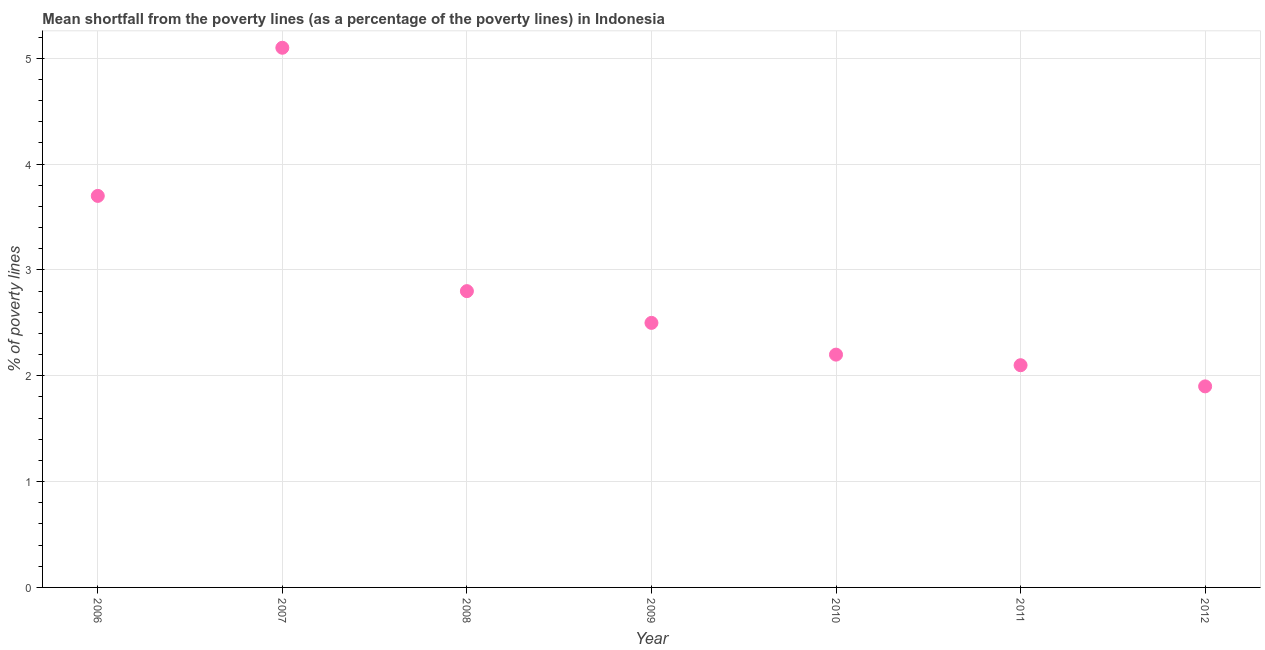What is the poverty gap at national poverty lines in 2006?
Offer a terse response. 3.7. In which year was the poverty gap at national poverty lines minimum?
Your answer should be very brief. 2012. What is the sum of the poverty gap at national poverty lines?
Ensure brevity in your answer.  20.3. What is the difference between the poverty gap at national poverty lines in 2008 and 2011?
Give a very brief answer. 0.7. What is the median poverty gap at national poverty lines?
Offer a very short reply. 2.5. What is the ratio of the poverty gap at national poverty lines in 2008 to that in 2009?
Make the answer very short. 1.12. Is the difference between the poverty gap at national poverty lines in 2009 and 2011 greater than the difference between any two years?
Your answer should be compact. No. What is the difference between the highest and the second highest poverty gap at national poverty lines?
Provide a short and direct response. 1.4. Is the sum of the poverty gap at national poverty lines in 2009 and 2011 greater than the maximum poverty gap at national poverty lines across all years?
Provide a short and direct response. No. What is the difference between the highest and the lowest poverty gap at national poverty lines?
Keep it short and to the point. 3.2. In how many years, is the poverty gap at national poverty lines greater than the average poverty gap at national poverty lines taken over all years?
Your answer should be very brief. 2. How many years are there in the graph?
Offer a very short reply. 7. Are the values on the major ticks of Y-axis written in scientific E-notation?
Offer a terse response. No. What is the title of the graph?
Provide a short and direct response. Mean shortfall from the poverty lines (as a percentage of the poverty lines) in Indonesia. What is the label or title of the Y-axis?
Your answer should be compact. % of poverty lines. What is the % of poverty lines in 2008?
Give a very brief answer. 2.8. What is the % of poverty lines in 2011?
Your answer should be compact. 2.1. What is the difference between the % of poverty lines in 2006 and 2007?
Give a very brief answer. -1.4. What is the difference between the % of poverty lines in 2006 and 2009?
Your answer should be compact. 1.2. What is the difference between the % of poverty lines in 2006 and 2012?
Your response must be concise. 1.8. What is the difference between the % of poverty lines in 2007 and 2008?
Give a very brief answer. 2.3. What is the difference between the % of poverty lines in 2007 and 2011?
Your response must be concise. 3. What is the difference between the % of poverty lines in 2008 and 2009?
Your answer should be compact. 0.3. What is the difference between the % of poverty lines in 2008 and 2010?
Your response must be concise. 0.6. What is the difference between the % of poverty lines in 2008 and 2012?
Offer a terse response. 0.9. What is the difference between the % of poverty lines in 2009 and 2010?
Your answer should be very brief. 0.3. What is the difference between the % of poverty lines in 2009 and 2012?
Provide a short and direct response. 0.6. What is the difference between the % of poverty lines in 2010 and 2011?
Provide a short and direct response. 0.1. What is the difference between the % of poverty lines in 2010 and 2012?
Your response must be concise. 0.3. What is the ratio of the % of poverty lines in 2006 to that in 2007?
Provide a succinct answer. 0.72. What is the ratio of the % of poverty lines in 2006 to that in 2008?
Offer a terse response. 1.32. What is the ratio of the % of poverty lines in 2006 to that in 2009?
Your answer should be very brief. 1.48. What is the ratio of the % of poverty lines in 2006 to that in 2010?
Give a very brief answer. 1.68. What is the ratio of the % of poverty lines in 2006 to that in 2011?
Your response must be concise. 1.76. What is the ratio of the % of poverty lines in 2006 to that in 2012?
Give a very brief answer. 1.95. What is the ratio of the % of poverty lines in 2007 to that in 2008?
Your answer should be very brief. 1.82. What is the ratio of the % of poverty lines in 2007 to that in 2009?
Your response must be concise. 2.04. What is the ratio of the % of poverty lines in 2007 to that in 2010?
Ensure brevity in your answer.  2.32. What is the ratio of the % of poverty lines in 2007 to that in 2011?
Keep it short and to the point. 2.43. What is the ratio of the % of poverty lines in 2007 to that in 2012?
Your answer should be compact. 2.68. What is the ratio of the % of poverty lines in 2008 to that in 2009?
Keep it short and to the point. 1.12. What is the ratio of the % of poverty lines in 2008 to that in 2010?
Your answer should be very brief. 1.27. What is the ratio of the % of poverty lines in 2008 to that in 2011?
Your answer should be compact. 1.33. What is the ratio of the % of poverty lines in 2008 to that in 2012?
Your response must be concise. 1.47. What is the ratio of the % of poverty lines in 2009 to that in 2010?
Your answer should be very brief. 1.14. What is the ratio of the % of poverty lines in 2009 to that in 2011?
Provide a succinct answer. 1.19. What is the ratio of the % of poverty lines in 2009 to that in 2012?
Make the answer very short. 1.32. What is the ratio of the % of poverty lines in 2010 to that in 2011?
Ensure brevity in your answer.  1.05. What is the ratio of the % of poverty lines in 2010 to that in 2012?
Offer a very short reply. 1.16. What is the ratio of the % of poverty lines in 2011 to that in 2012?
Your answer should be compact. 1.1. 